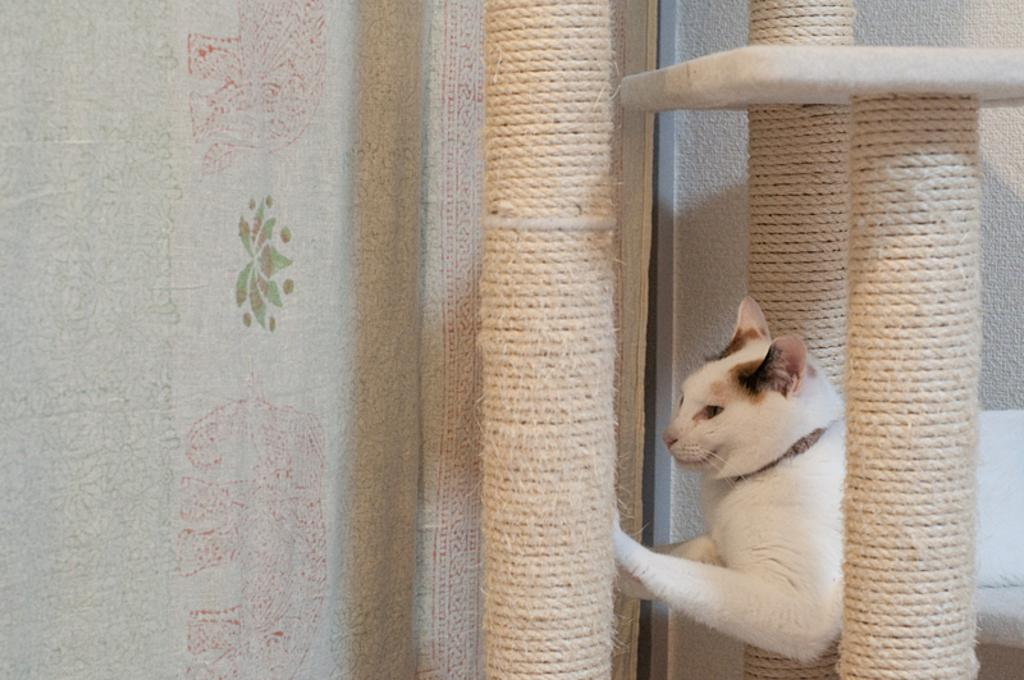What type of animal is in the image? There is a cat in the image. Can you describe the cat's appearance? The cat has white and brown colors. What objects are attached to poles in the image? There are ropes attached to poles in the image. What color is the background curtain? The background curtain is white in color. What type of faucet is visible in the image? There is no faucet present in the image. How much salt is on the cat's fur in the image? There is no salt visible on the cat's fur in the image. 